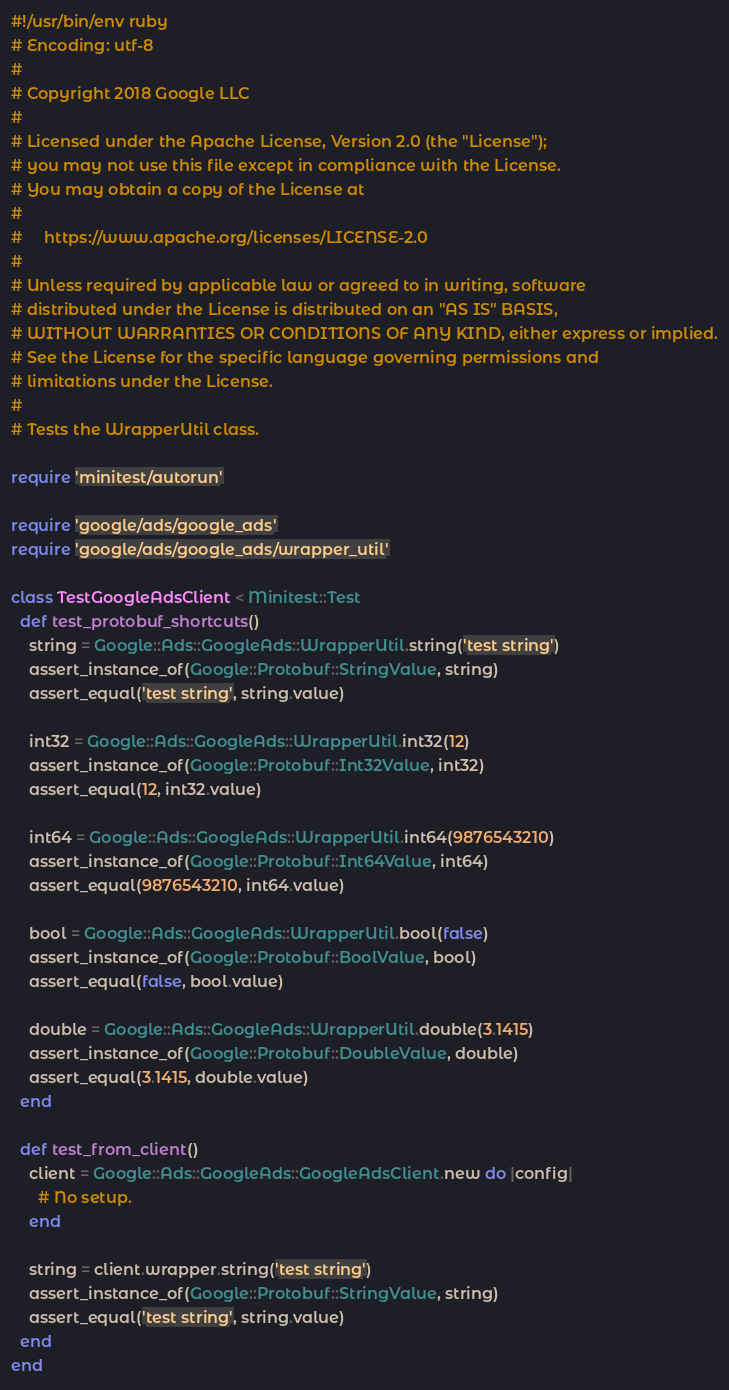<code> <loc_0><loc_0><loc_500><loc_500><_Ruby_>#!/usr/bin/env ruby
# Encoding: utf-8
#
# Copyright 2018 Google LLC
#
# Licensed under the Apache License, Version 2.0 (the "License");
# you may not use this file except in compliance with the License.
# You may obtain a copy of the License at
#
#     https://www.apache.org/licenses/LICENSE-2.0
#
# Unless required by applicable law or agreed to in writing, software
# distributed under the License is distributed on an "AS IS" BASIS,
# WITHOUT WARRANTIES OR CONDITIONS OF ANY KIND, either express or implied.
# See the License for the specific language governing permissions and
# limitations under the License.
#
# Tests the WrapperUtil class.

require 'minitest/autorun'

require 'google/ads/google_ads'
require 'google/ads/google_ads/wrapper_util'

class TestGoogleAdsClient < Minitest::Test
  def test_protobuf_shortcuts()
    string = Google::Ads::GoogleAds::WrapperUtil.string('test string')
    assert_instance_of(Google::Protobuf::StringValue, string)
    assert_equal('test string', string.value)

    int32 = Google::Ads::GoogleAds::WrapperUtil.int32(12)
    assert_instance_of(Google::Protobuf::Int32Value, int32)
    assert_equal(12, int32.value)

    int64 = Google::Ads::GoogleAds::WrapperUtil.int64(9876543210)
    assert_instance_of(Google::Protobuf::Int64Value, int64)
    assert_equal(9876543210, int64.value)

    bool = Google::Ads::GoogleAds::WrapperUtil.bool(false)
    assert_instance_of(Google::Protobuf::BoolValue, bool)
    assert_equal(false, bool.value)

    double = Google::Ads::GoogleAds::WrapperUtil.double(3.1415)
    assert_instance_of(Google::Protobuf::DoubleValue, double)
    assert_equal(3.1415, double.value)
  end

  def test_from_client()
    client = Google::Ads::GoogleAds::GoogleAdsClient.new do |config|
      # No setup.
    end

    string = client.wrapper.string('test string')
    assert_instance_of(Google::Protobuf::StringValue, string)
    assert_equal('test string', string.value)
  end
end
</code> 